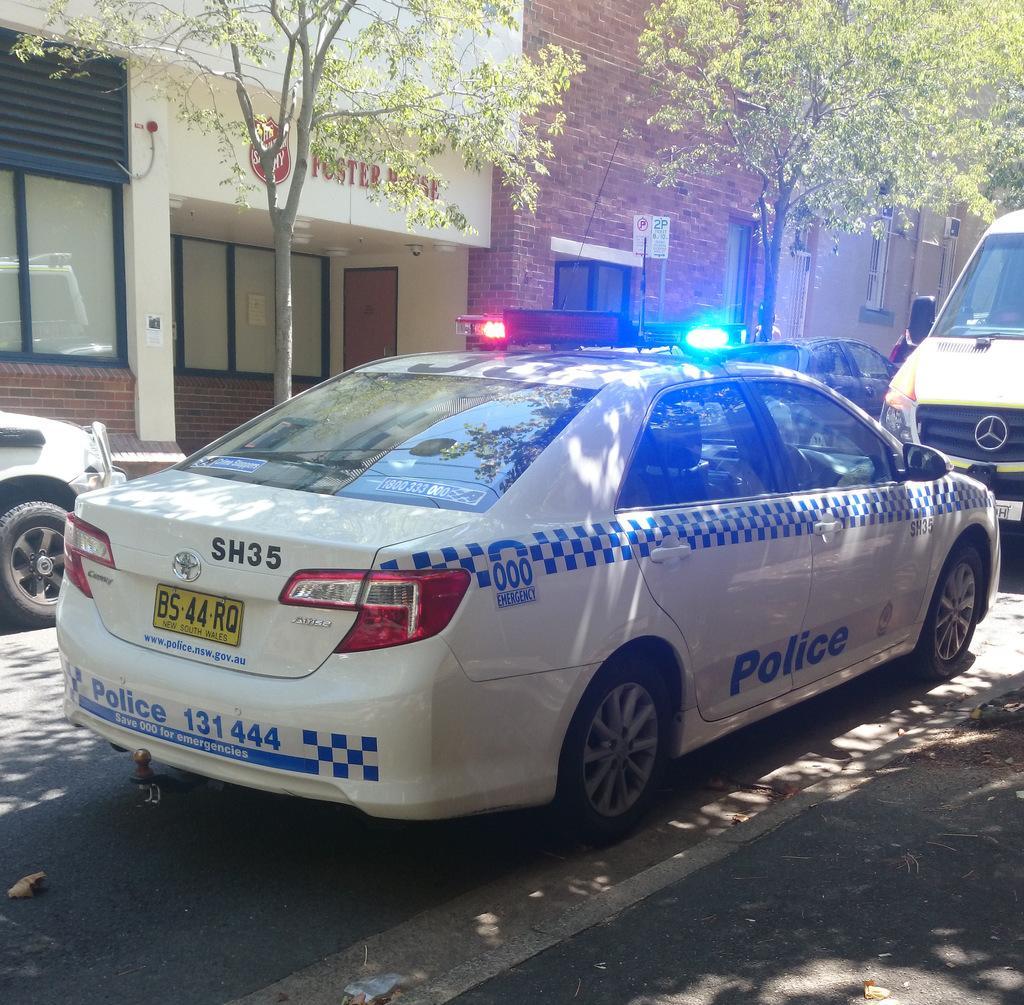Can you describe this image briefly? In this image there are vehicles on a road, in the background there are trees and buildings. 